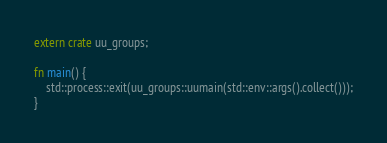Convert code to text. <code><loc_0><loc_0><loc_500><loc_500><_Rust_>extern crate uu_groups;

fn main() {
    std::process::exit(uu_groups::uumain(std::env::args().collect()));
}
</code> 